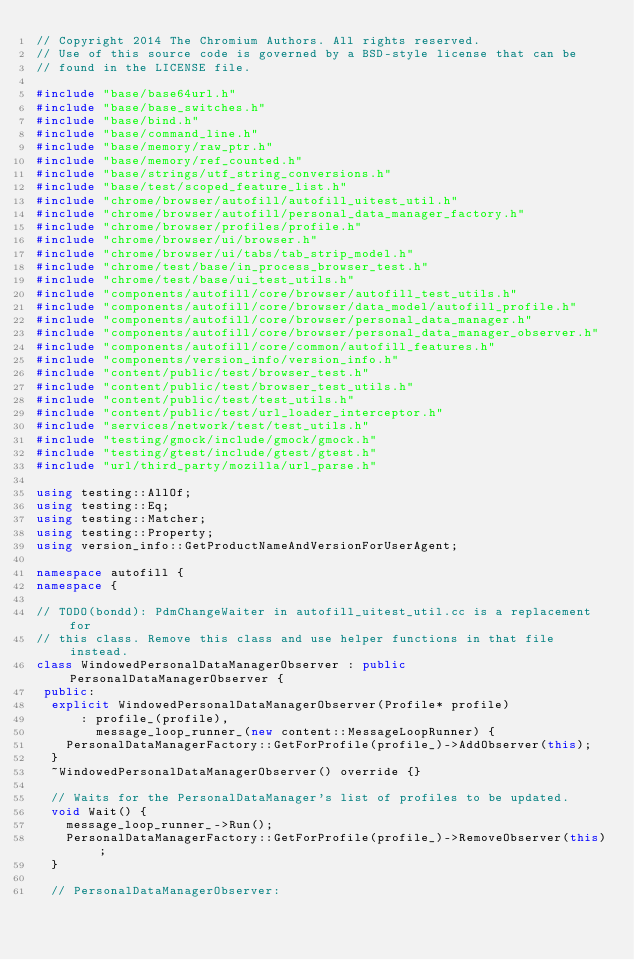Convert code to text. <code><loc_0><loc_0><loc_500><loc_500><_C++_>// Copyright 2014 The Chromium Authors. All rights reserved.
// Use of this source code is governed by a BSD-style license that can be
// found in the LICENSE file.

#include "base/base64url.h"
#include "base/base_switches.h"
#include "base/bind.h"
#include "base/command_line.h"
#include "base/memory/raw_ptr.h"
#include "base/memory/ref_counted.h"
#include "base/strings/utf_string_conversions.h"
#include "base/test/scoped_feature_list.h"
#include "chrome/browser/autofill/autofill_uitest_util.h"
#include "chrome/browser/autofill/personal_data_manager_factory.h"
#include "chrome/browser/profiles/profile.h"
#include "chrome/browser/ui/browser.h"
#include "chrome/browser/ui/tabs/tab_strip_model.h"
#include "chrome/test/base/in_process_browser_test.h"
#include "chrome/test/base/ui_test_utils.h"
#include "components/autofill/core/browser/autofill_test_utils.h"
#include "components/autofill/core/browser/data_model/autofill_profile.h"
#include "components/autofill/core/browser/personal_data_manager.h"
#include "components/autofill/core/browser/personal_data_manager_observer.h"
#include "components/autofill/core/common/autofill_features.h"
#include "components/version_info/version_info.h"
#include "content/public/test/browser_test.h"
#include "content/public/test/browser_test_utils.h"
#include "content/public/test/test_utils.h"
#include "content/public/test/url_loader_interceptor.h"
#include "services/network/test/test_utils.h"
#include "testing/gmock/include/gmock/gmock.h"
#include "testing/gtest/include/gtest/gtest.h"
#include "url/third_party/mozilla/url_parse.h"

using testing::AllOf;
using testing::Eq;
using testing::Matcher;
using testing::Property;
using version_info::GetProductNameAndVersionForUserAgent;

namespace autofill {
namespace {

// TODO(bondd): PdmChangeWaiter in autofill_uitest_util.cc is a replacement for
// this class. Remove this class and use helper functions in that file instead.
class WindowedPersonalDataManagerObserver : public PersonalDataManagerObserver {
 public:
  explicit WindowedPersonalDataManagerObserver(Profile* profile)
      : profile_(profile),
        message_loop_runner_(new content::MessageLoopRunner) {
    PersonalDataManagerFactory::GetForProfile(profile_)->AddObserver(this);
  }
  ~WindowedPersonalDataManagerObserver() override {}

  // Waits for the PersonalDataManager's list of profiles to be updated.
  void Wait() {
    message_loop_runner_->Run();
    PersonalDataManagerFactory::GetForProfile(profile_)->RemoveObserver(this);
  }

  // PersonalDataManagerObserver:</code> 